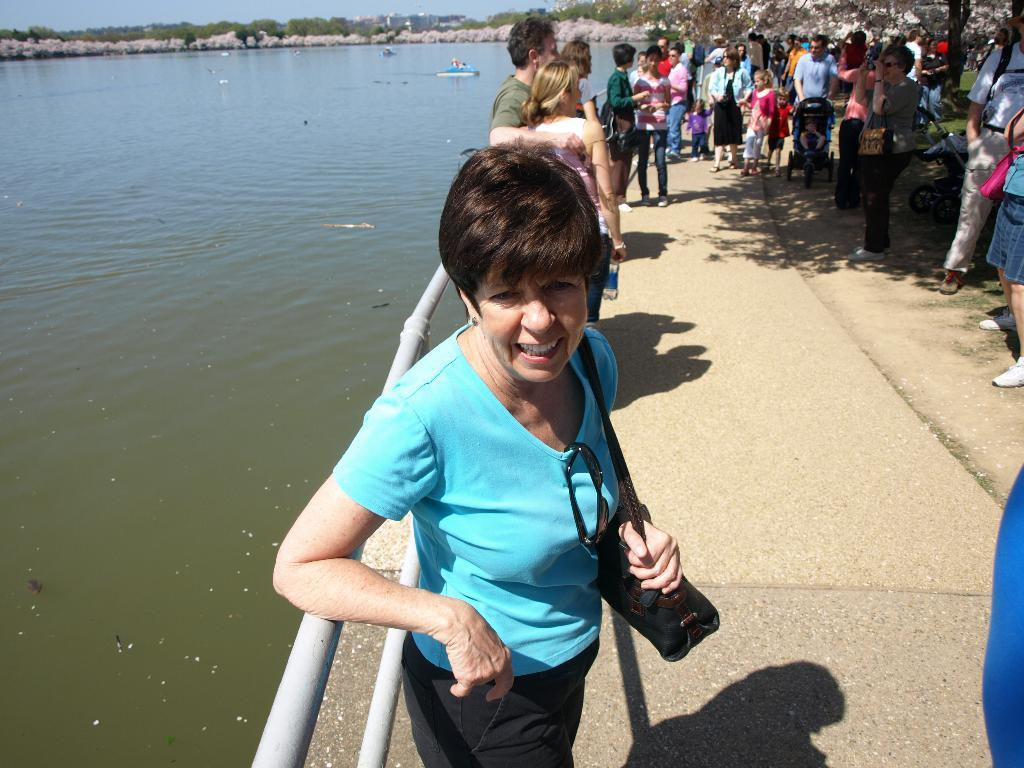Who or what can be seen in the image? There are people in the image. What objects are present in the image? There are rods, baby chairs, and a bag visible in the image. What is the natural environment like in the image? There are trees and sky visible in the background of the image. What is the water in the image being used for? The water is visible in the image, but its purpose is not specified. What is the woman in the image holding? A woman is holding a bag in the image. What flavor of ice cream is the woman's friend enjoying in the image? There is no ice cream or friend present in the image. 